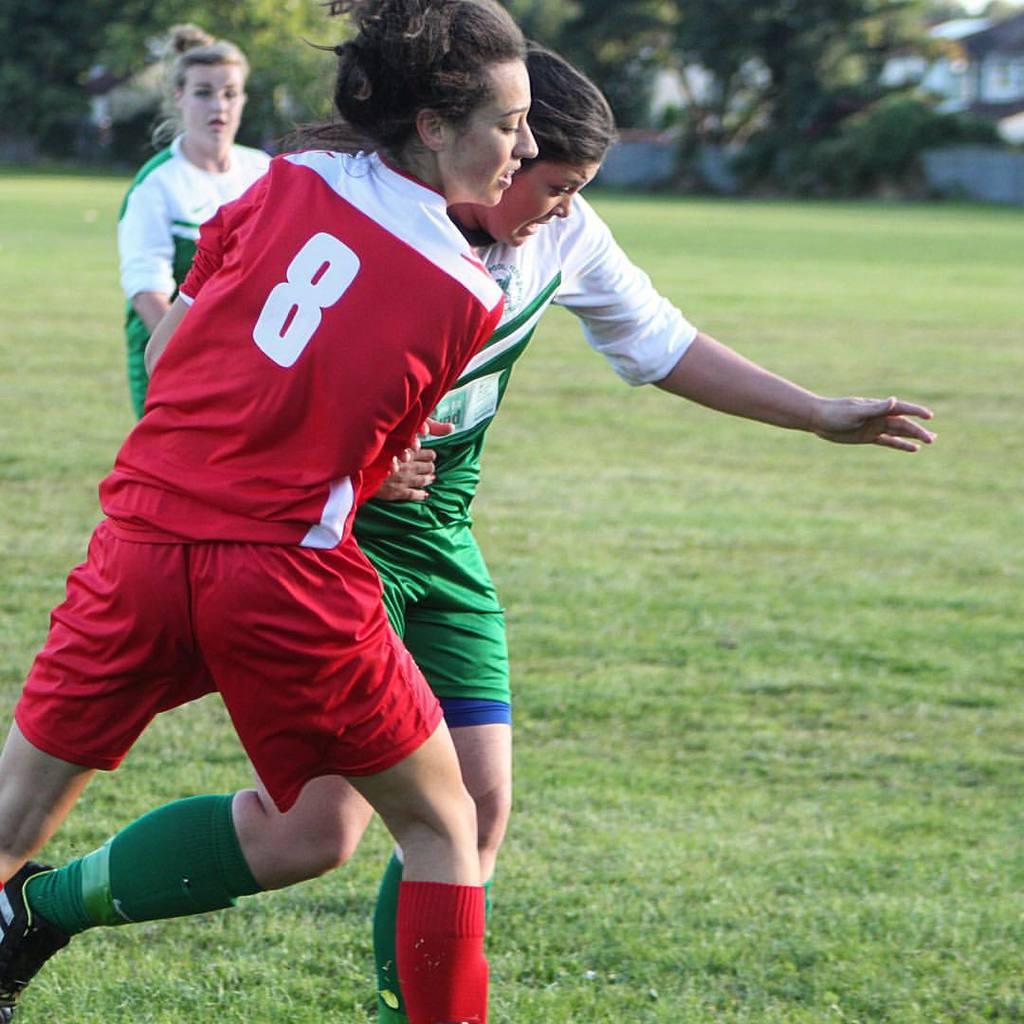What player number is in red?
Offer a terse response. 8. 